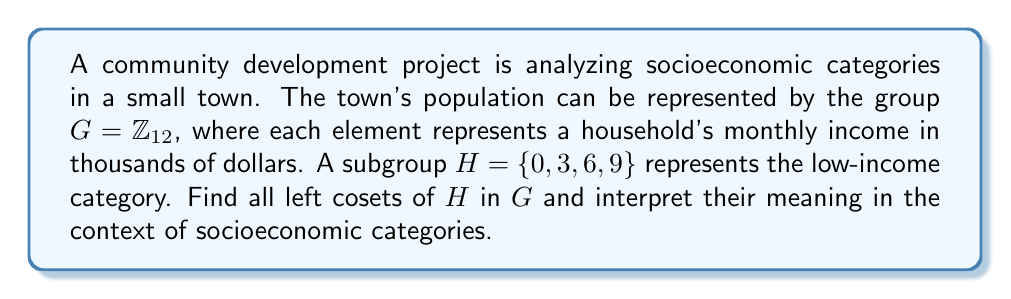Provide a solution to this math problem. 1) First, let's identify the elements of $G = \mathbb{Z}_{12}$:
   $G = \{0, 1, 2, 3, 4, 5, 6, 7, 8, 9, 10, 11\}$

2) The subgroup $H = \{0, 3, 6, 9\}$ represents the low-income category.

3) To find the left cosets, we need to compute $a + H$ for each $a \in G$:

   $0 + H = \{0, 3, 6, 9\}$ (low-income)
   $1 + H = \{1, 4, 7, 10\}$ (lower-middle income)
   $2 + H = \{2, 5, 8, 11\}$ (upper-middle income)

4) We don't need to continue, as these three cosets cover all elements of $G$.

5) Interpretation:
   - $0 + H$: Households earning $0-3k, $3-6k, $6-9k, or $9-12k (wrapping around)
   - $1 + H$: Households earning $1-4k, $4-7k, $7-10k, or $10-13k (mod 12)
   - $2 + H$: Households earning $2-5k, $5-8k, $8-11k, or $11-14k (mod 12)

6) These cosets represent three distinct socioeconomic categories in the town, each containing households with similar income levels.
Answer: $\{0, 3, 6, 9\}$, $\{1, 4, 7, 10\}$, $\{2, 5, 8, 11\}$ 